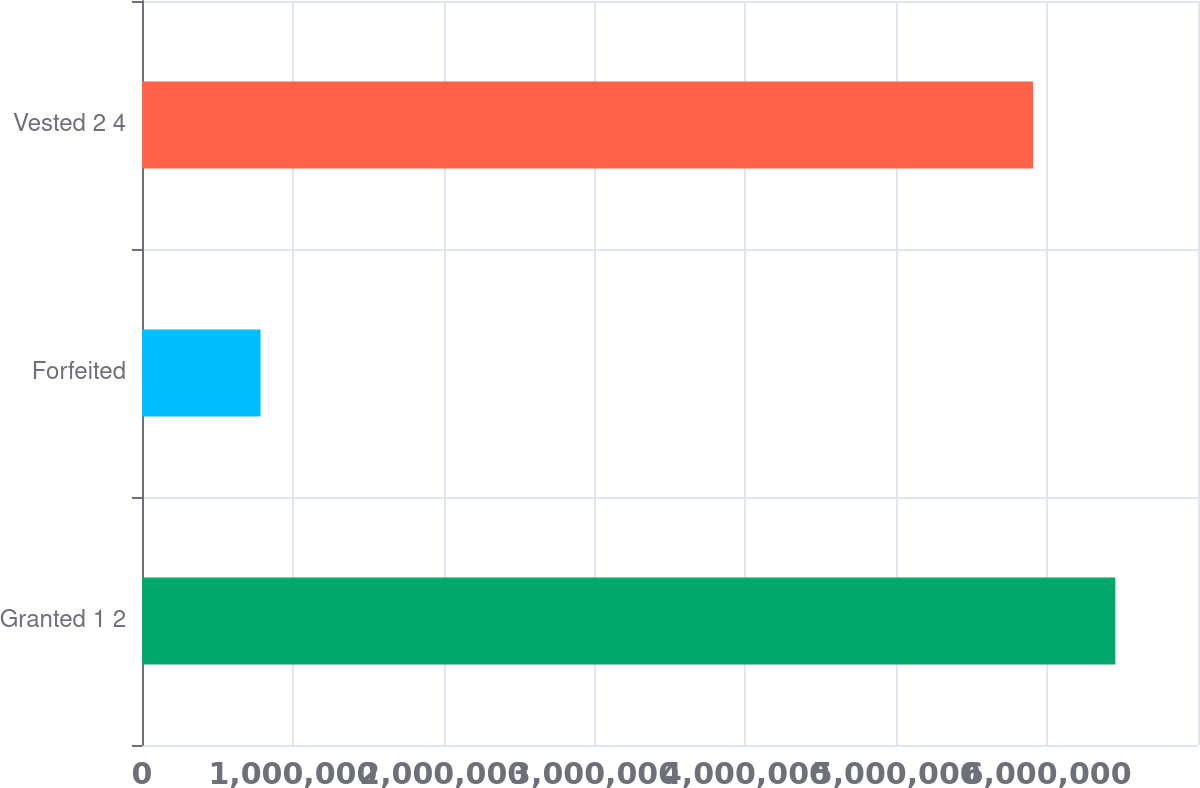Convert chart. <chart><loc_0><loc_0><loc_500><loc_500><bar_chart><fcel>Granted 1 2<fcel>Forfeited<fcel>Vested 2 4<nl><fcel>6.45219e+06<fcel>785926<fcel>5.90769e+06<nl></chart> 